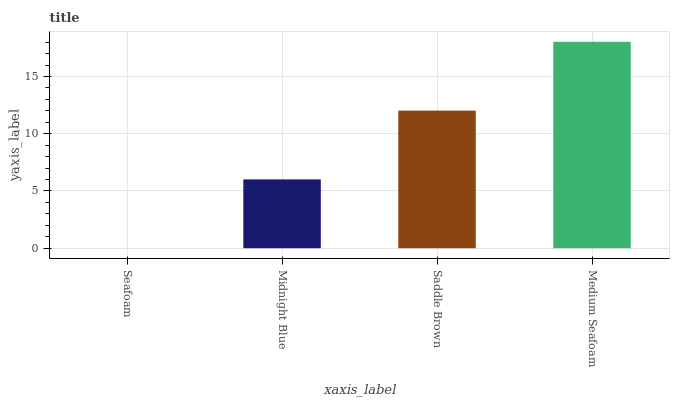Is Seafoam the minimum?
Answer yes or no. Yes. Is Medium Seafoam the maximum?
Answer yes or no. Yes. Is Midnight Blue the minimum?
Answer yes or no. No. Is Midnight Blue the maximum?
Answer yes or no. No. Is Midnight Blue greater than Seafoam?
Answer yes or no. Yes. Is Seafoam less than Midnight Blue?
Answer yes or no. Yes. Is Seafoam greater than Midnight Blue?
Answer yes or no. No. Is Midnight Blue less than Seafoam?
Answer yes or no. No. Is Saddle Brown the high median?
Answer yes or no. Yes. Is Midnight Blue the low median?
Answer yes or no. Yes. Is Midnight Blue the high median?
Answer yes or no. No. Is Seafoam the low median?
Answer yes or no. No. 